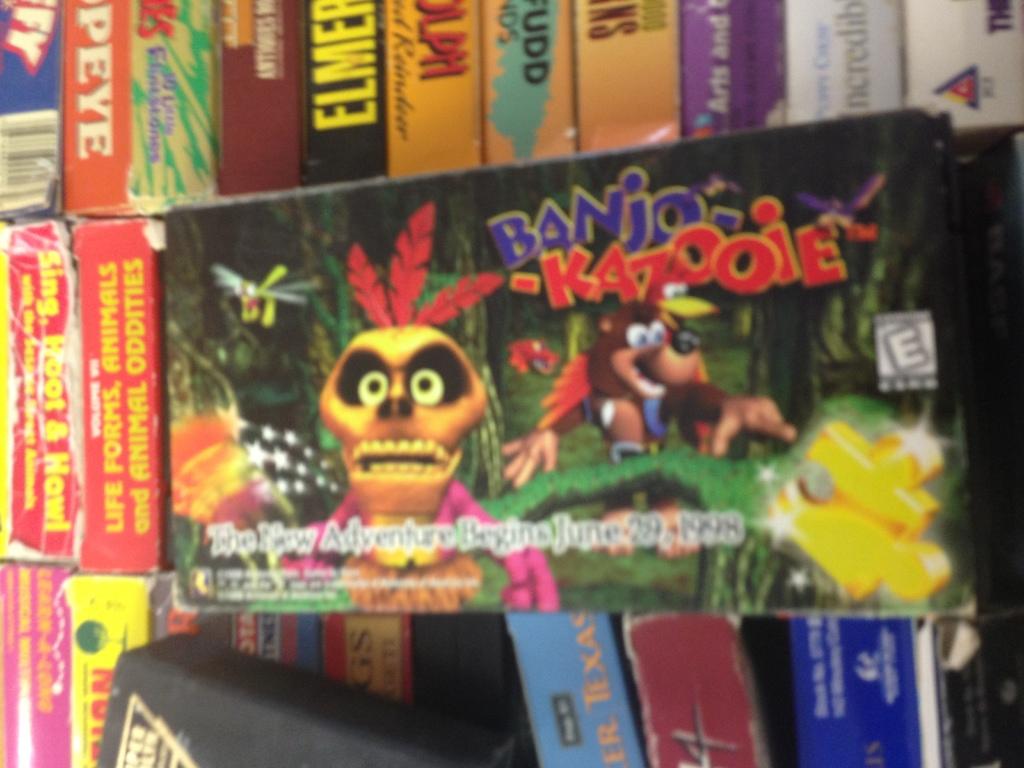When does the adventure begin?
Offer a terse response. June 29, 1998. What is the title of the video game displayed above the brown bear and red bird?
Your response must be concise. Banjo kazooie. 